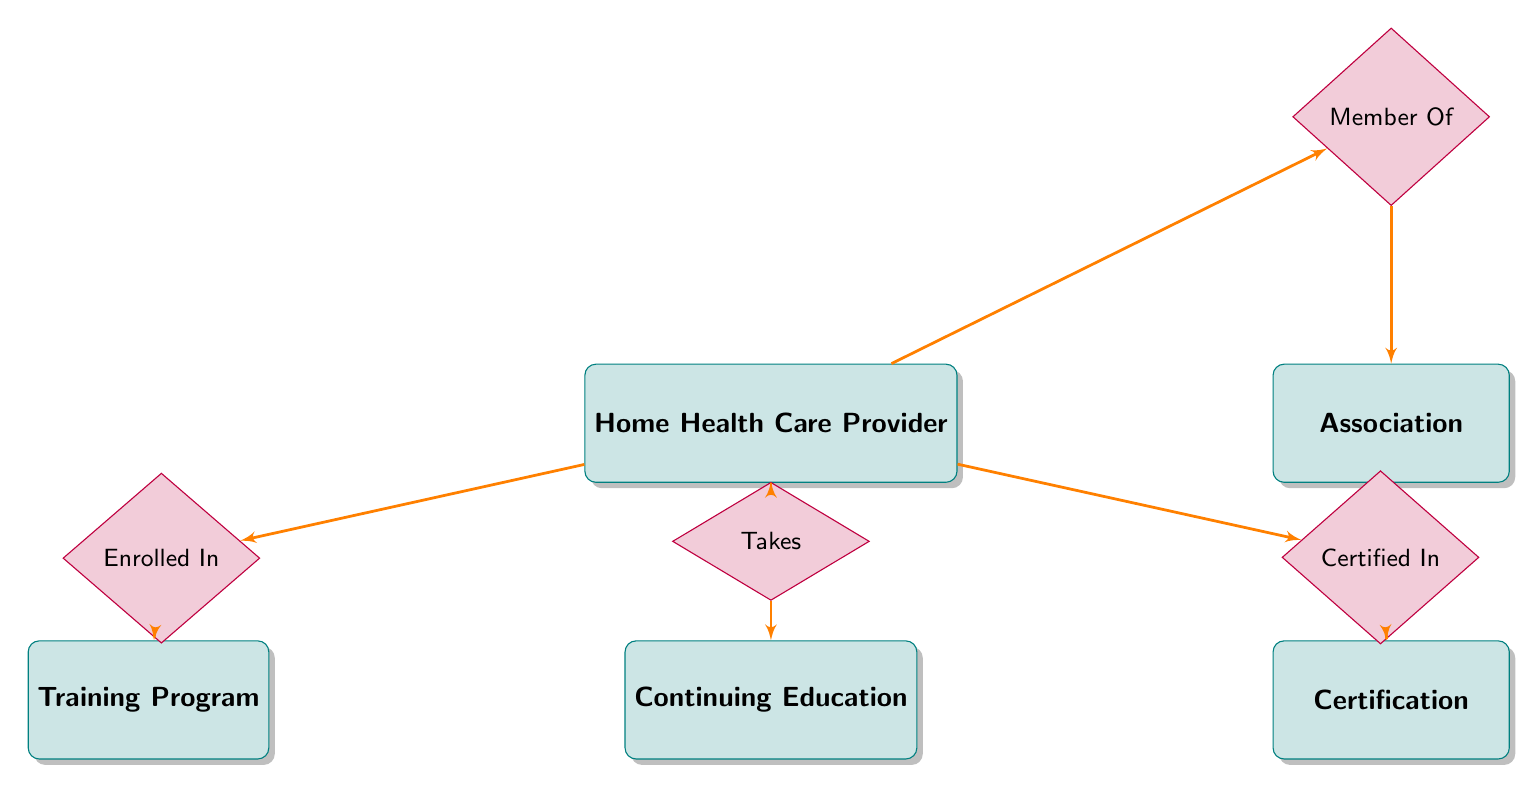What is the total number of entities in the diagram? The diagram contains five entities: Home Health Care Provider, Training Program, Certification, Continuing Education, and Association. Counting these entities gives a total of five.
Answer: 5 Which entity is related to the relationship "Certified In"? The "Certified In" relationship connects Home Health Care Provider with the Certification entity. Therefore, the related entity is Certification.
Answer: Certification What type of relationship connects Home Health Care Provider and Association? The relationship connecting Home Health Care Provider and Association is labeled as "Member Of." This indicates that home health care providers can be members of different associations.
Answer: Member Of How many relationships are shown in the diagram? There are four relationships depicted in the diagram: Enrolled In, Certified In, Takes, and Member Of. Counting these gives a total of four relationships.
Answer: 4 Which entity has a direct relationship with the Training Program? The Training Program entity directly relates to Home Health Care Provider through the relationship "Enrolled In." This indicates that providers can enroll in training programs.
Answer: Home Health Care Provider What is the significance of the relationship "Takes" in this diagram? The "Takes" relationship connects Home Health Care Provider with Continuing Education, which signifies that home health care providers participate in continuing education courses to maintain or enhance their skills.
Answer: Continuing Education What type of education opportunities do Home Health Care Providers pursue according to the diagram? According to the diagram, Home Health Care Providers pursue various continuing education opportunities as represented by the Continuing Education entity connected through the "Takes" relationship.
Answer: Continuing Education How many attributes does the Home Health Care Provider entity have? The Home Health Care Provider entity includes five attributes: ProviderID, Name, Phone, Email, and Address. Counting these attributes gives a total of five.
Answer: 5 